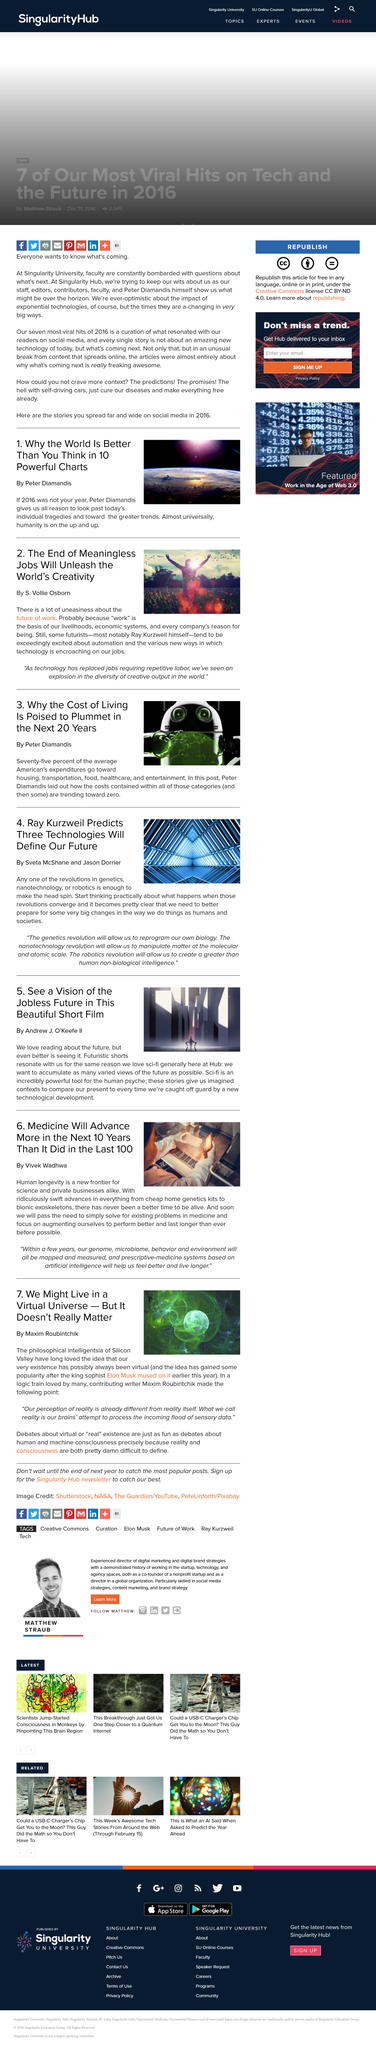Indicate a few pertinent items in this graphic. The title of the article is 'What is the name of the title of the article? We Might Live in a Virtual Universe - But it Doesn't Really Matter..' Maxim Roubintchik wrote this article. Ray Kurzweil is the futurist mentioned in the second article. According to Vivek Wadhwa, medicine will advance more in the next 10 years than it did in the last 100 years. The costs of housing, transportation, food, healthcare, and entertainment are expected to decrease to zero in the future. 